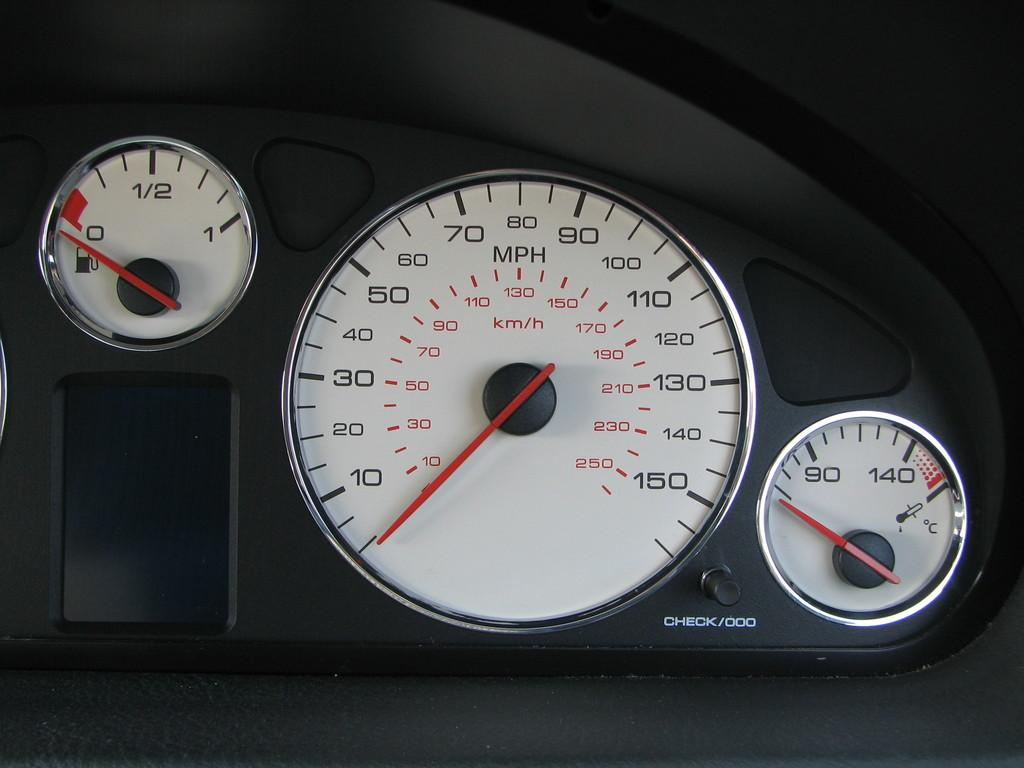What type of instrument is visible in the image? There is a speedometer in the image. What other instrument can be seen in the image? There is a fuel tank in the image. Are there any additional instruments in the image? Yes, there is a temperature gauge in the image. What type of necklace is hanging from the speedometer in the image? There is no necklace present in the image; it features a speedometer, fuel tank, and temperature gauge. Is there any water visible in the image? There is no water present in the image. 